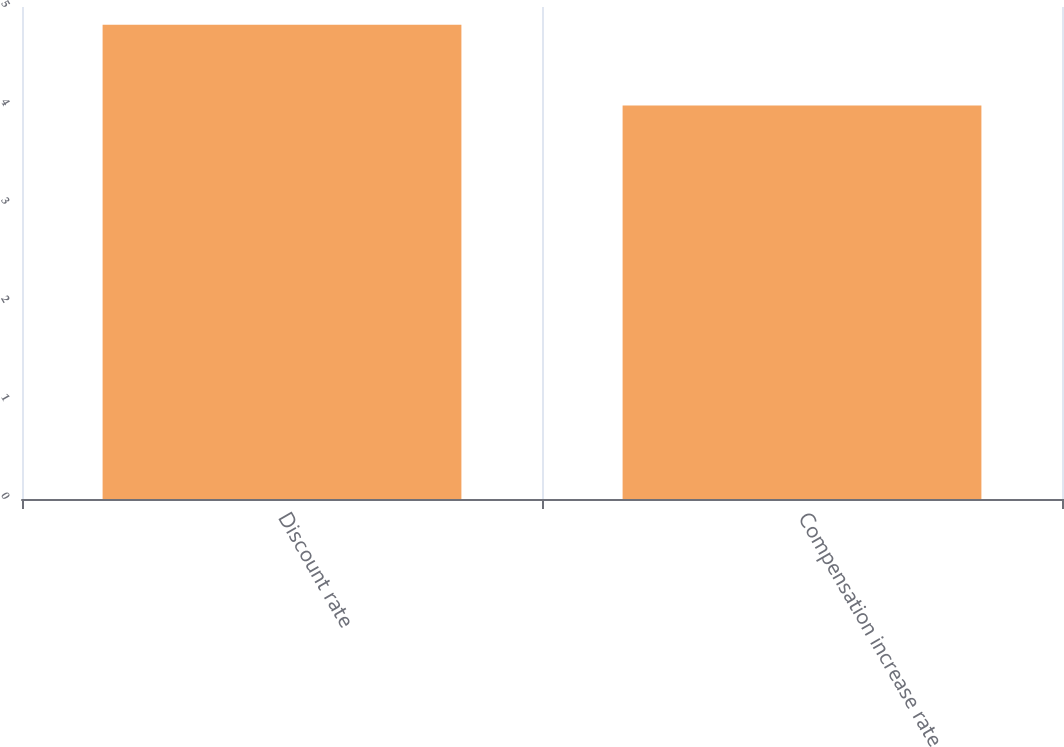<chart> <loc_0><loc_0><loc_500><loc_500><bar_chart><fcel>Discount rate<fcel>Compensation increase rate<nl><fcel>4.82<fcel>4<nl></chart> 